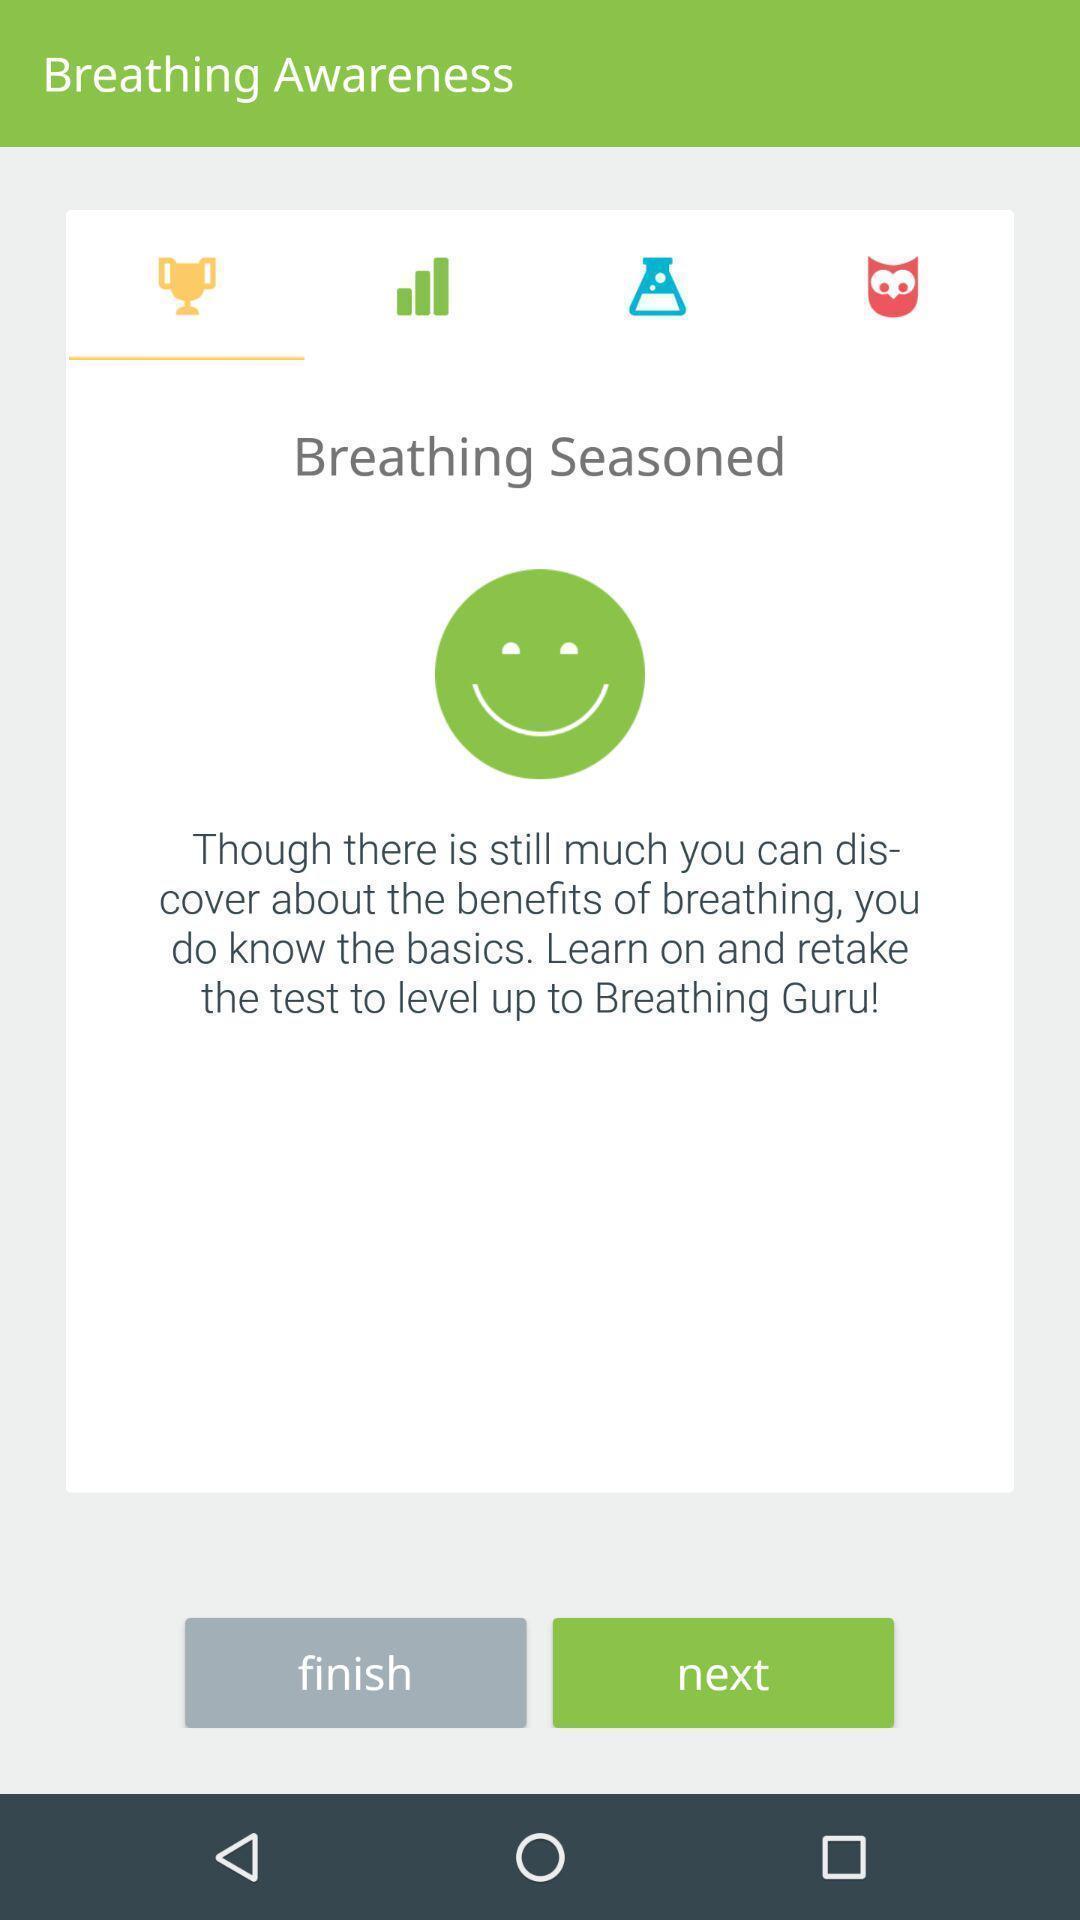Tell me what you see in this picture. Page displaying with information about breathing and few options. 